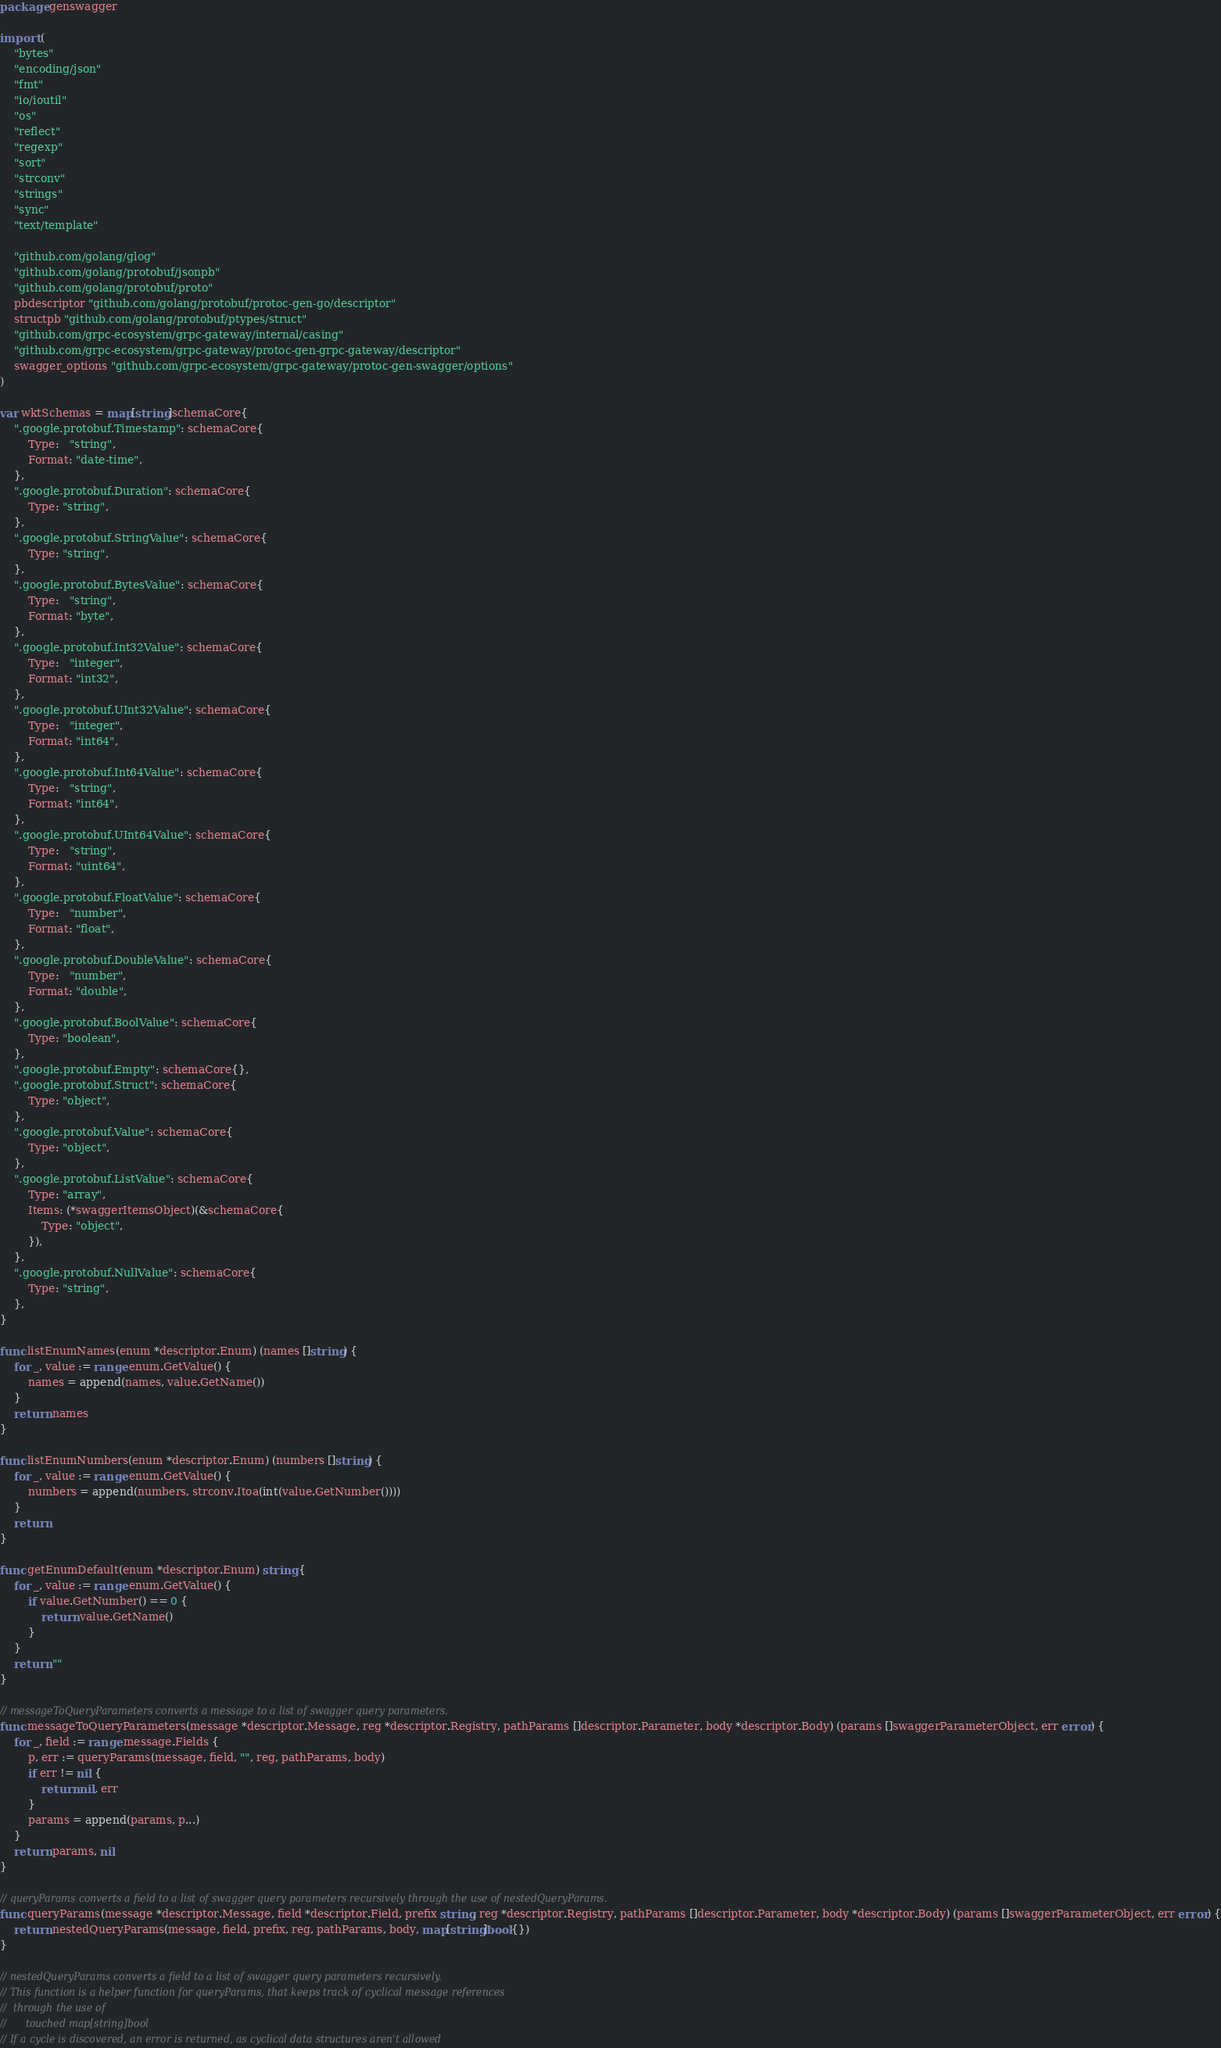Convert code to text. <code><loc_0><loc_0><loc_500><loc_500><_Go_>package genswagger

import (
	"bytes"
	"encoding/json"
	"fmt"
	"io/ioutil"
	"os"
	"reflect"
	"regexp"
	"sort"
	"strconv"
	"strings"
	"sync"
	"text/template"

	"github.com/golang/glog"
	"github.com/golang/protobuf/jsonpb"
	"github.com/golang/protobuf/proto"
	pbdescriptor "github.com/golang/protobuf/protoc-gen-go/descriptor"
	structpb "github.com/golang/protobuf/ptypes/struct"
	"github.com/grpc-ecosystem/grpc-gateway/internal/casing"
	"github.com/grpc-ecosystem/grpc-gateway/protoc-gen-grpc-gateway/descriptor"
	swagger_options "github.com/grpc-ecosystem/grpc-gateway/protoc-gen-swagger/options"
)

var wktSchemas = map[string]schemaCore{
	".google.protobuf.Timestamp": schemaCore{
		Type:   "string",
		Format: "date-time",
	},
	".google.protobuf.Duration": schemaCore{
		Type: "string",
	},
	".google.protobuf.StringValue": schemaCore{
		Type: "string",
	},
	".google.protobuf.BytesValue": schemaCore{
		Type:   "string",
		Format: "byte",
	},
	".google.protobuf.Int32Value": schemaCore{
		Type:   "integer",
		Format: "int32",
	},
	".google.protobuf.UInt32Value": schemaCore{
		Type:   "integer",
		Format: "int64",
	},
	".google.protobuf.Int64Value": schemaCore{
		Type:   "string",
		Format: "int64",
	},
	".google.protobuf.UInt64Value": schemaCore{
		Type:   "string",
		Format: "uint64",
	},
	".google.protobuf.FloatValue": schemaCore{
		Type:   "number",
		Format: "float",
	},
	".google.protobuf.DoubleValue": schemaCore{
		Type:   "number",
		Format: "double",
	},
	".google.protobuf.BoolValue": schemaCore{
		Type: "boolean",
	},
	".google.protobuf.Empty": schemaCore{},
	".google.protobuf.Struct": schemaCore{
		Type: "object",
	},
	".google.protobuf.Value": schemaCore{
		Type: "object",
	},
	".google.protobuf.ListValue": schemaCore{
		Type: "array",
		Items: (*swaggerItemsObject)(&schemaCore{
			Type: "object",
		}),
	},
	".google.protobuf.NullValue": schemaCore{
		Type: "string",
	},
}

func listEnumNames(enum *descriptor.Enum) (names []string) {
	for _, value := range enum.GetValue() {
		names = append(names, value.GetName())
	}
	return names
}

func listEnumNumbers(enum *descriptor.Enum) (numbers []string) {
	for _, value := range enum.GetValue() {
		numbers = append(numbers, strconv.Itoa(int(value.GetNumber())))
	}
	return
}

func getEnumDefault(enum *descriptor.Enum) string {
	for _, value := range enum.GetValue() {
		if value.GetNumber() == 0 {
			return value.GetName()
		}
	}
	return ""
}

// messageToQueryParameters converts a message to a list of swagger query parameters.
func messageToQueryParameters(message *descriptor.Message, reg *descriptor.Registry, pathParams []descriptor.Parameter, body *descriptor.Body) (params []swaggerParameterObject, err error) {
	for _, field := range message.Fields {
		p, err := queryParams(message, field, "", reg, pathParams, body)
		if err != nil {
			return nil, err
		}
		params = append(params, p...)
	}
	return params, nil
}

// queryParams converts a field to a list of swagger query parameters recursively through the use of nestedQueryParams.
func queryParams(message *descriptor.Message, field *descriptor.Field, prefix string, reg *descriptor.Registry, pathParams []descriptor.Parameter, body *descriptor.Body) (params []swaggerParameterObject, err error) {
	return nestedQueryParams(message, field, prefix, reg, pathParams, body, map[string]bool{})
}

// nestedQueryParams converts a field to a list of swagger query parameters recursively.
// This function is a helper function for queryParams, that keeps track of cyclical message references
//  through the use of
//      touched map[string]bool
// If a cycle is discovered, an error is returned, as cyclical data structures aren't allowed</code> 